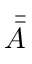<formula> <loc_0><loc_0><loc_500><loc_500>\bar { \bar { A } }</formula> 